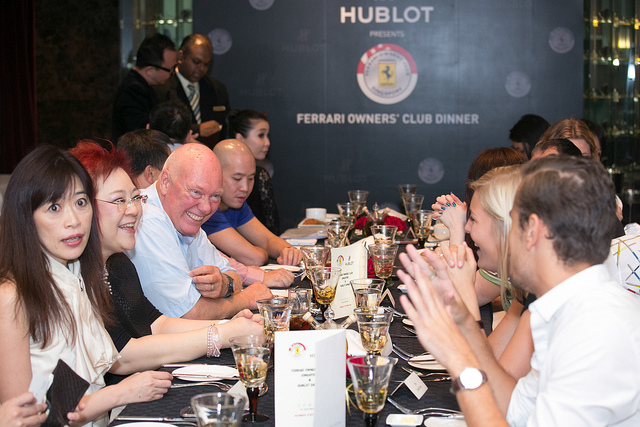Read all the text in this image. CLUB DINNER HUBLOT FERRARI OWNERS 